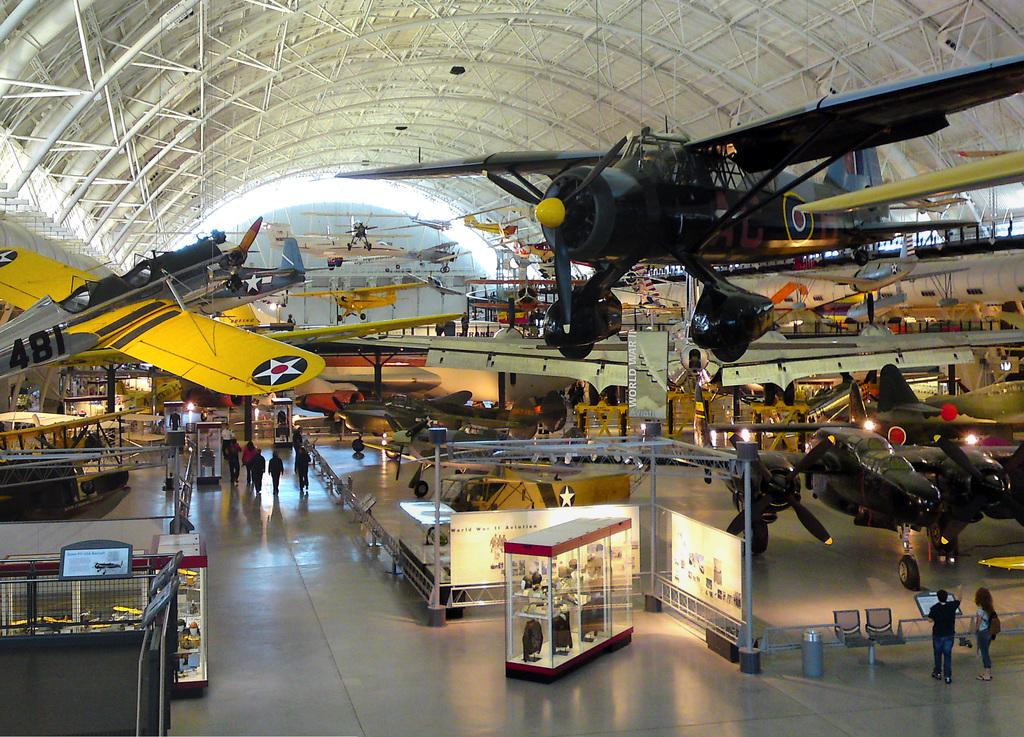Provide a one-sentence caption for the provided image. An airplane with number 481 on it hangs from the ceiling of a museum. 